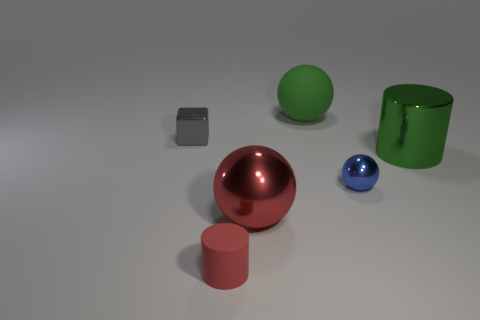Is the color of the sphere that is behind the small gray cube the same as the large cylinder? Yes, the sphere positioned behind the small gray cube and the large cylinder both share the same vibrant green color, demonstrating a pleasing visual harmony in their coloration. 